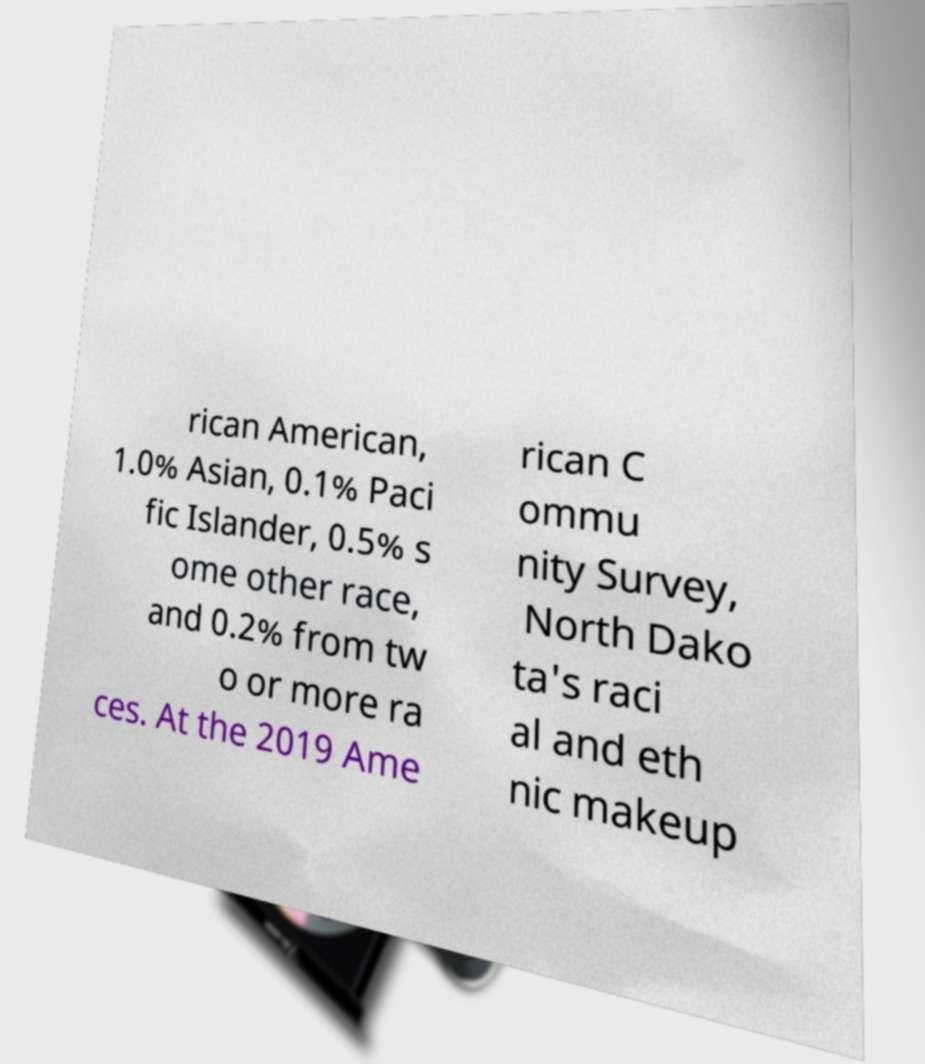Please identify and transcribe the text found in this image. rican American, 1.0% Asian, 0.1% Paci fic Islander, 0.5% s ome other race, and 0.2% from tw o or more ra ces. At the 2019 Ame rican C ommu nity Survey, North Dako ta's raci al and eth nic makeup 